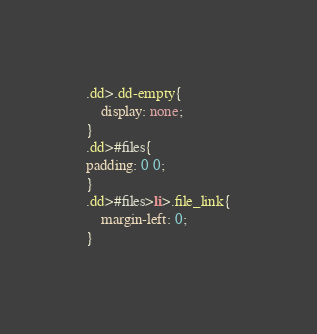Convert code to text. <code><loc_0><loc_0><loc_500><loc_500><_CSS_>.dd>.dd-empty{
    display: none;
}
.dd>#files{
padding: 0 0;
}
.dd>#files>li>.file_link{
    margin-left: 0;
}</code> 